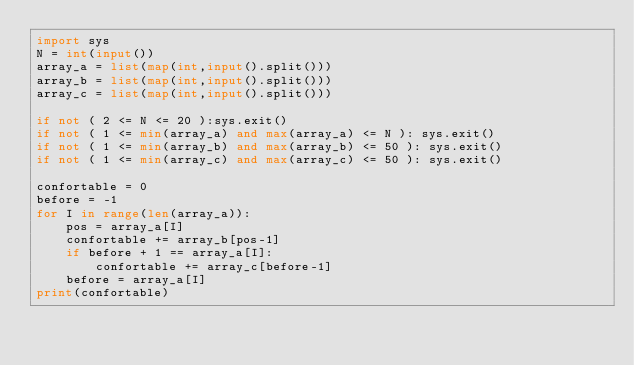Convert code to text. <code><loc_0><loc_0><loc_500><loc_500><_Python_>import sys
N = int(input())
array_a = list(map(int,input().split()))
array_b = list(map(int,input().split()))
array_c = list(map(int,input().split()))

if not ( 2 <= N <= 20 ):sys.exit()
if not ( 1 <= min(array_a) and max(array_a) <= N ): sys.exit()
if not ( 1 <= min(array_b) and max(array_b) <= 50 ): sys.exit()
if not ( 1 <= min(array_c) and max(array_c) <= 50 ): sys.exit()

confortable = 0
before = -1
for I in range(len(array_a)):
    pos = array_a[I]
    confortable += array_b[pos-1]
    if before + 1 == array_a[I]:
        confortable += array_c[before-1]
    before = array_a[I]
print(confortable)</code> 